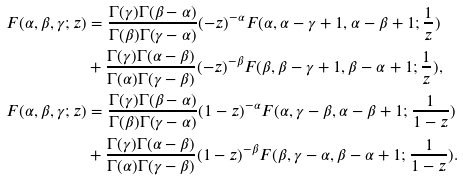Convert formula to latex. <formula><loc_0><loc_0><loc_500><loc_500>F ( \alpha , \beta , \gamma ; z ) & = \frac { \Gamma ( \gamma ) \Gamma ( \beta - \alpha ) } { \Gamma ( \beta ) \Gamma ( \gamma - \alpha ) } ( - z ) ^ { - \alpha } F ( \alpha , \alpha - \gamma + 1 , \alpha - \beta + 1 ; \frac { 1 } { z } ) \\ & + \frac { \Gamma ( \gamma ) \Gamma ( \alpha - \beta ) } { \Gamma ( \alpha ) \Gamma ( \gamma - \beta ) } ( - z ) ^ { - \beta } F ( \beta , \beta - \gamma + 1 , \beta - \alpha + 1 ; \frac { 1 } { z } ) , \\ F ( \alpha , \beta , \gamma ; z ) & = \frac { \Gamma ( \gamma ) \Gamma ( \beta - \alpha ) } { \Gamma ( \beta ) \Gamma ( \gamma - \alpha ) } ( 1 - z ) ^ { - \alpha } F ( \alpha , \gamma - \beta , \alpha - \beta + 1 ; \frac { 1 } { 1 - z } ) \\ & + \frac { \Gamma ( \gamma ) \Gamma ( \alpha - \beta ) } { \Gamma ( \alpha ) \Gamma ( \gamma - \beta ) } ( 1 - z ) ^ { - \beta } F ( \beta , \gamma - \alpha , \beta - \alpha + 1 ; \frac { 1 } { 1 - z } ) .</formula> 